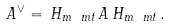Convert formula to latex. <formula><loc_0><loc_0><loc_500><loc_500>A ^ { \vee } = \, H _ { m \ m t } \, A \, H _ { m \ m t } \, .</formula> 